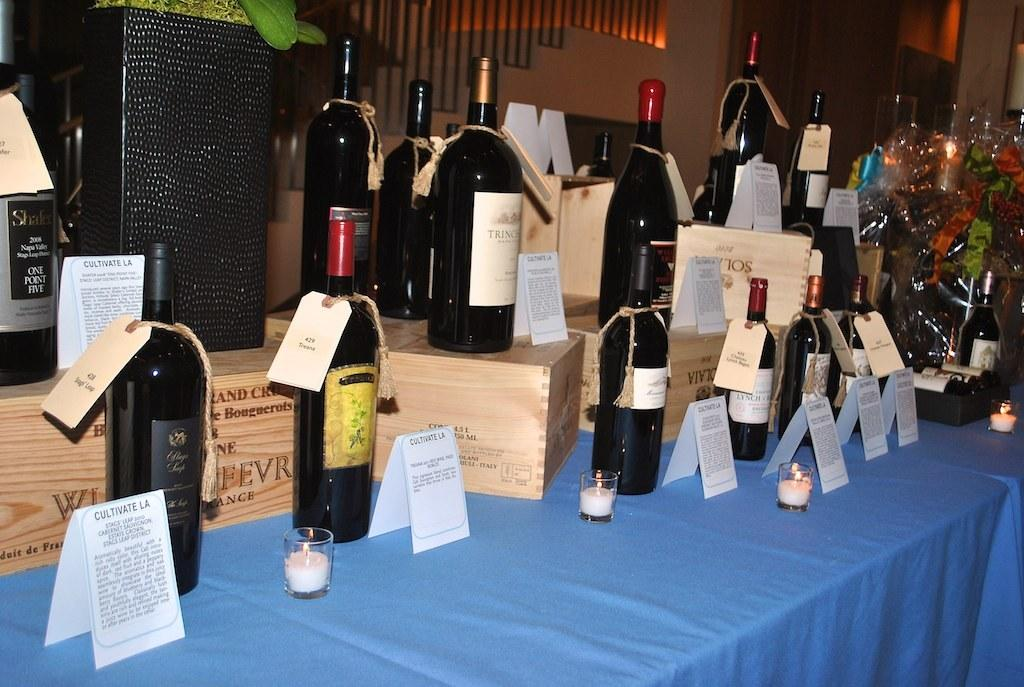<image>
Create a compact narrative representing the image presented. A bunch of wine bottles the one on the left being Cultivate LA. 